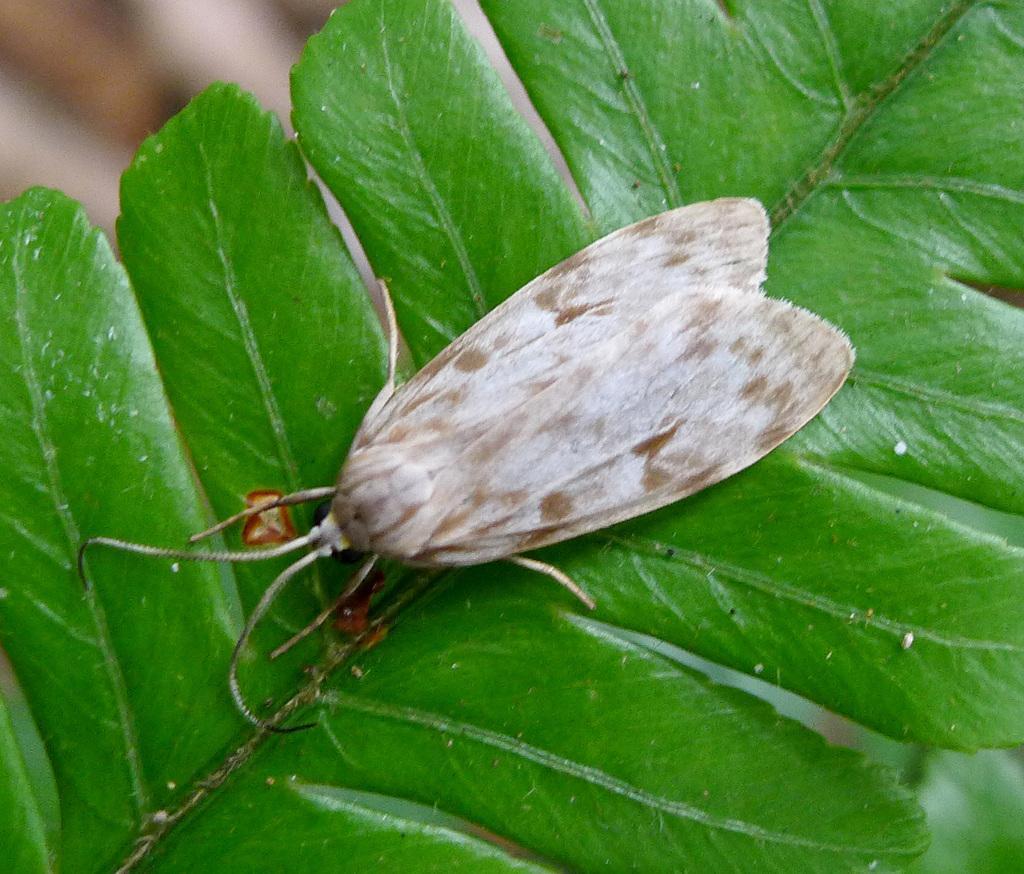How would you summarize this image in a sentence or two? There is an insect present on the leaves as we can see in the middle of this image. 